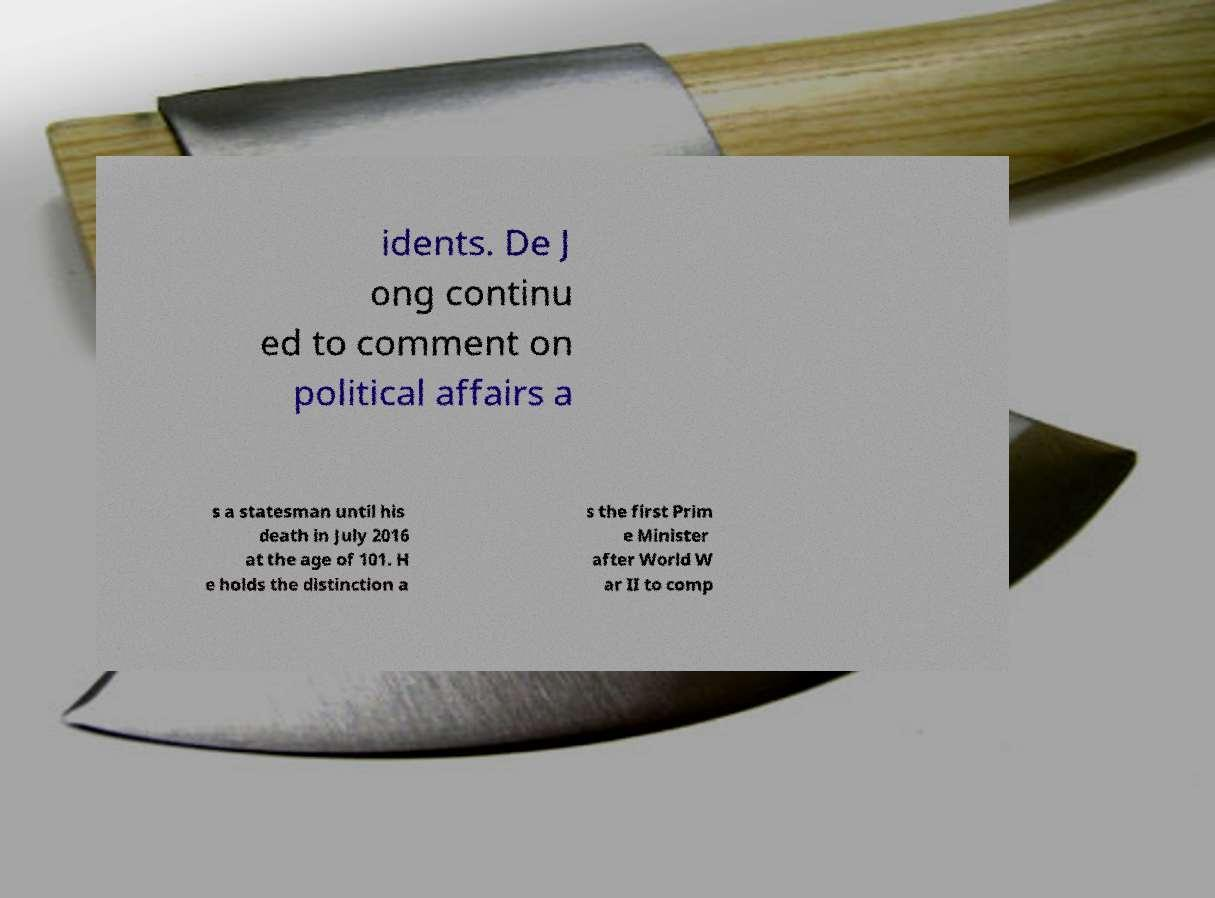Can you accurately transcribe the text from the provided image for me? idents. De J ong continu ed to comment on political affairs a s a statesman until his death in July 2016 at the age of 101. H e holds the distinction a s the first Prim e Minister after World W ar II to comp 